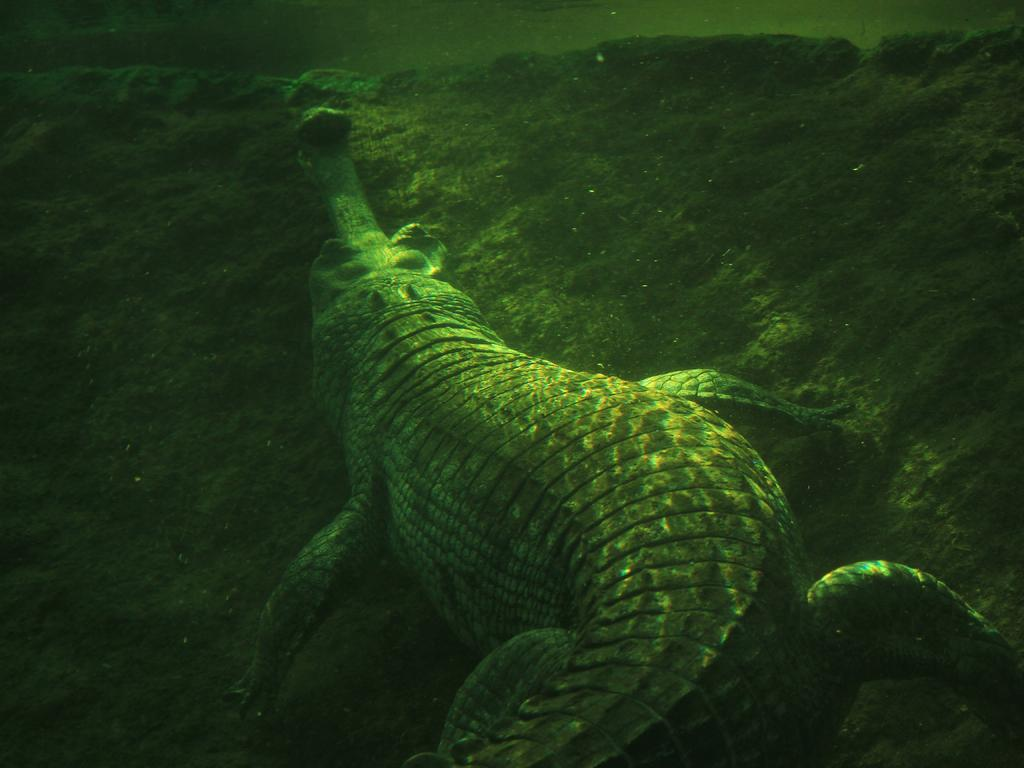What animal is present in the image? There is a crocodile in the image. Where is the crocodile located in the image? The crocodile is under the water and on a rock-like surface. What part of the image does this scene occupy? This scene is in the foreground of the image. What sense does the crocodile use to take pictures in the image? The crocodile does not use any sense to take pictures in the image, as it is an animal and not capable of using a camera. 